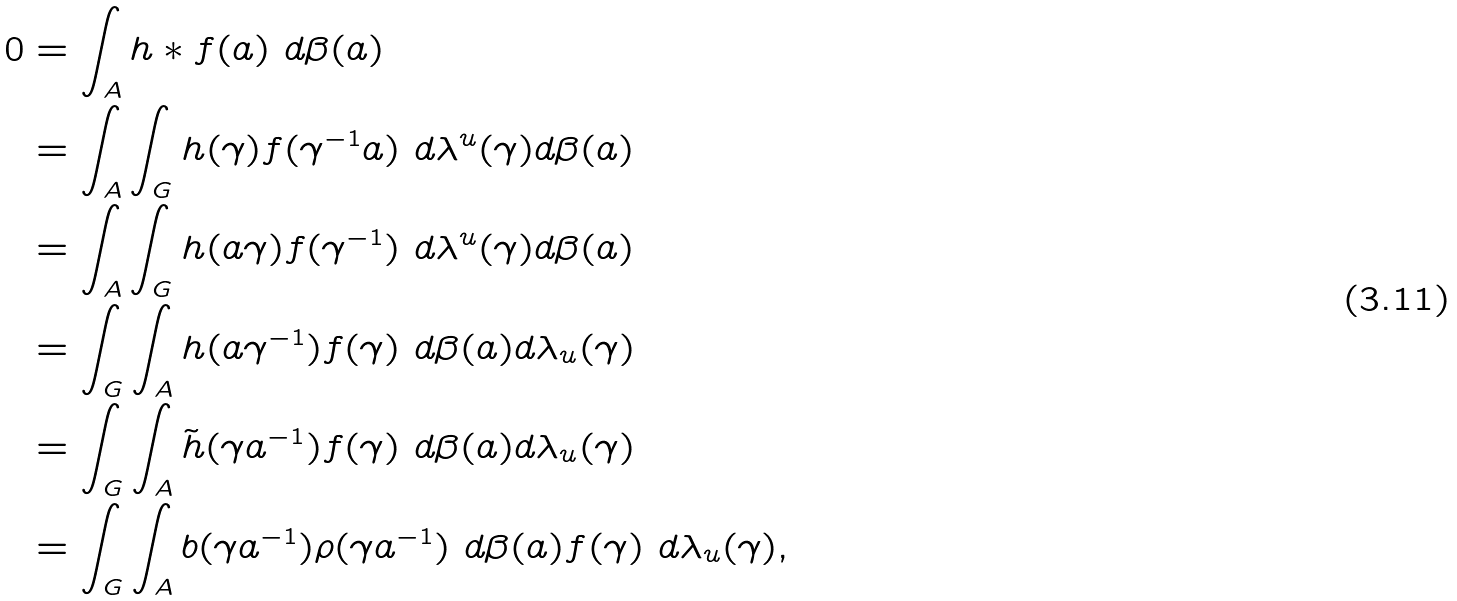<formula> <loc_0><loc_0><loc_500><loc_500>0 & = \int _ { A } h * f ( a ) \ d \beta ( a ) \\ & = \int _ { A } \int _ { G } h ( \gamma ) f ( \gamma ^ { - 1 } a ) \ d \lambda ^ { u } ( \gamma ) d \beta ( a ) \\ & = \int _ { A } \int _ { G } h ( a \gamma ) f ( \gamma ^ { - 1 } ) \ d \lambda ^ { u } ( \gamma ) d \beta ( a ) \\ & = \int _ { G } \int _ { A } h ( a \gamma ^ { - 1 } ) f ( \gamma ) \ d \beta ( a ) d \lambda _ { u } ( \gamma ) \\ & = \int _ { G } \int _ { A } \tilde { h } ( \gamma a ^ { - 1 } ) f ( \gamma ) \ d \beta ( a ) d \lambda _ { u } ( \gamma ) \\ & = \int _ { G } \int _ { A } b ( \gamma a ^ { - 1 } ) \rho ( \gamma a ^ { - 1 } ) \ d \beta ( a ) f ( \gamma ) \ d \lambda _ { u } ( \gamma ) ,</formula> 